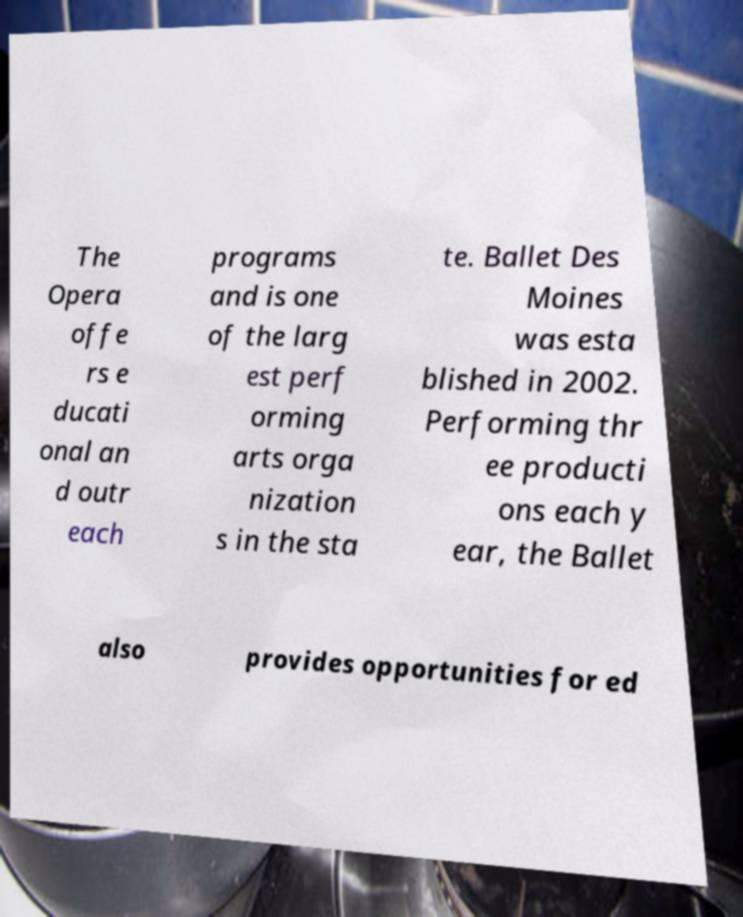Please read and relay the text visible in this image. What does it say? The Opera offe rs e ducati onal an d outr each programs and is one of the larg est perf orming arts orga nization s in the sta te. Ballet Des Moines was esta blished in 2002. Performing thr ee producti ons each y ear, the Ballet also provides opportunities for ed 